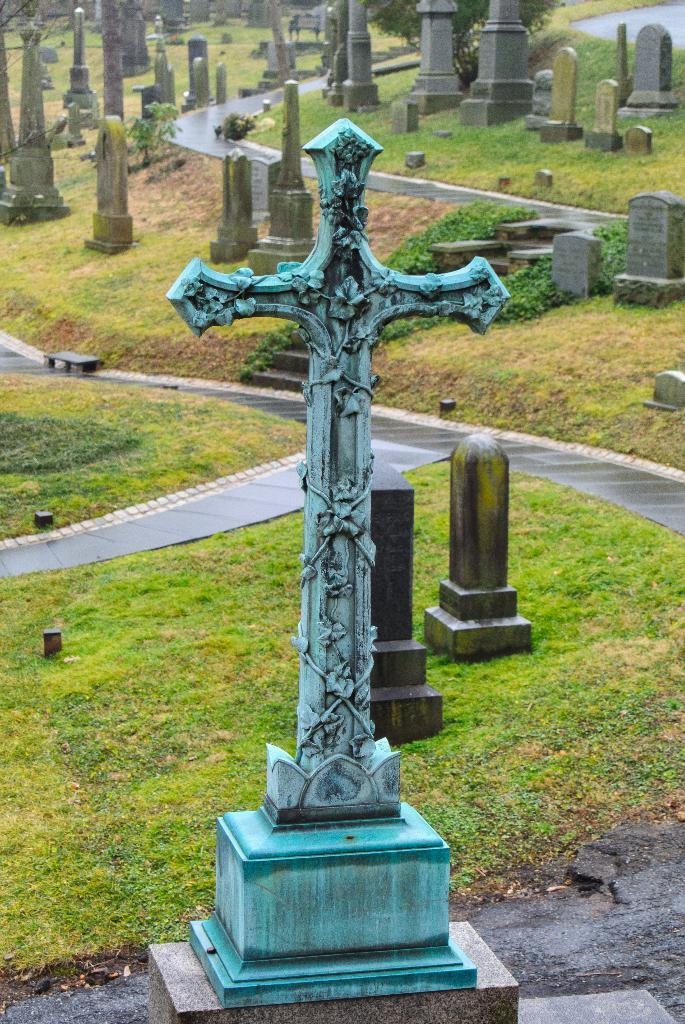What is the main subject of the image? The main subject of the image is a cross with sculptures. How is the cross positioned in the image? The cross is on a pedestal. What can be seen in the background of the image? There are graves in the background of the image. What type of vegetation is present in the image? There is grass on the ground in the image. What type of man-made structures can be seen in the image? There are roads visible in the image. What type of mint can be seen growing near the cross in the image? There is no mint visible in the image; the only vegetation mentioned is grass. What type of drink is being served at the dock in the image? There is no dock or drink present in the image. 